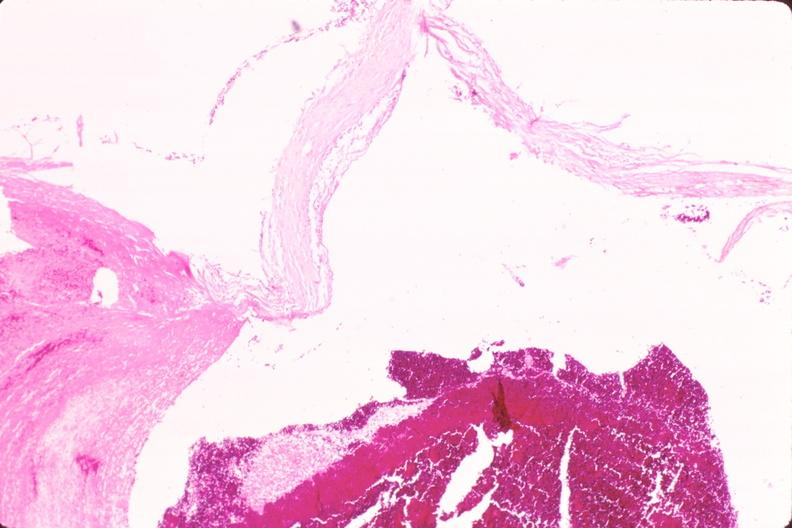what is present?
Answer the question using a single word or phrase. Cardiovascular 